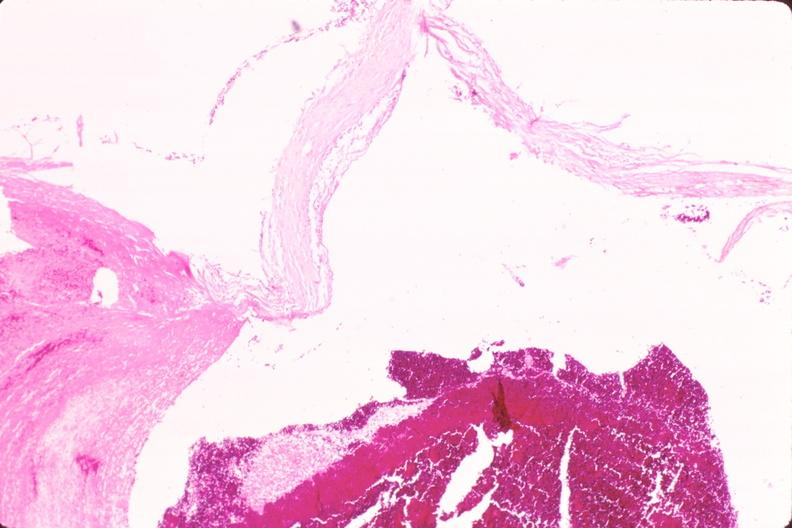what is present?
Answer the question using a single word or phrase. Cardiovascular 